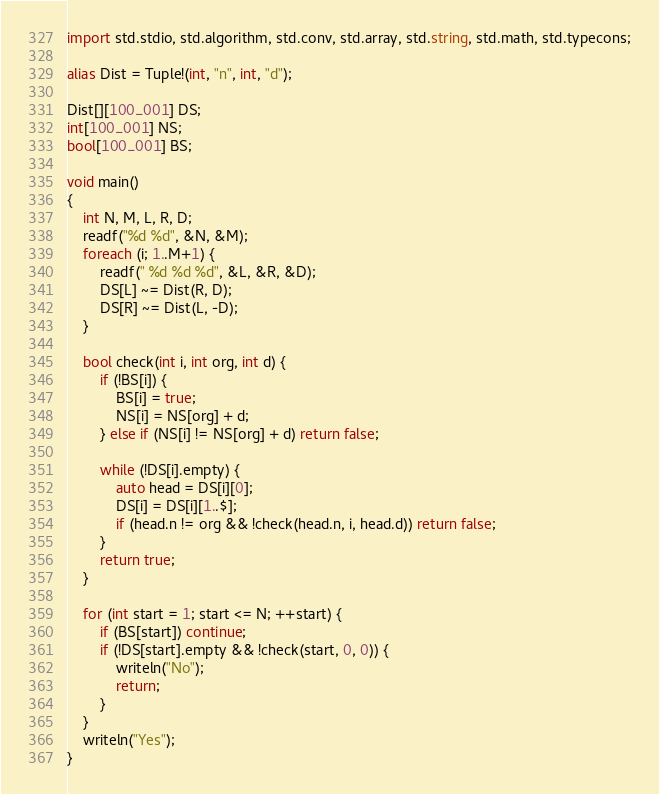<code> <loc_0><loc_0><loc_500><loc_500><_D_>import std.stdio, std.algorithm, std.conv, std.array, std.string, std.math, std.typecons;

alias Dist = Tuple!(int, "n", int, "d");

Dist[][100_001] DS;
int[100_001] NS;
bool[100_001] BS;

void main()
{
    int N, M, L, R, D;
    readf("%d %d", &N, &M);
    foreach (i; 1..M+1) {
        readf(" %d %d %d", &L, &R, &D);
        DS[L] ~= Dist(R, D);
        DS[R] ~= Dist(L, -D);
    }

    bool check(int i, int org, int d) {
        if (!BS[i]) {
            BS[i] = true;
            NS[i] = NS[org] + d;
        } else if (NS[i] != NS[org] + d) return false;

        while (!DS[i].empty) {
            auto head = DS[i][0];
            DS[i] = DS[i][1..$];
            if (head.n != org && !check(head.n, i, head.d)) return false;
        }
        return true;
    }

    for (int start = 1; start <= N; ++start) {
        if (BS[start]) continue;
        if (!DS[start].empty && !check(start, 0, 0)) {
            writeln("No");
            return;
        }
    }
    writeln("Yes");
}</code> 